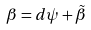Convert formula to latex. <formula><loc_0><loc_0><loc_500><loc_500>\beta = d \psi + \tilde { \beta }</formula> 